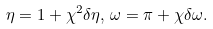<formula> <loc_0><loc_0><loc_500><loc_500>\eta = 1 + \chi ^ { 2 } \delta \eta , \, \omega = \pi + \chi \delta \omega .</formula> 